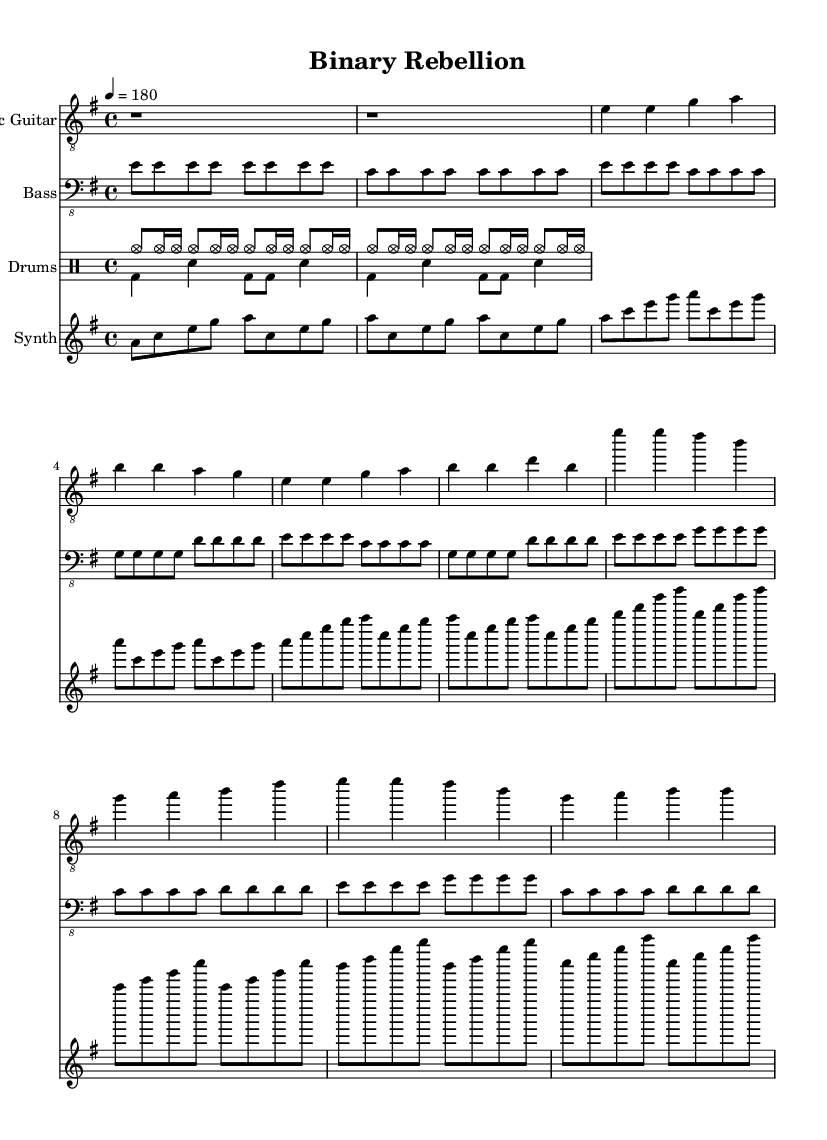What is the key signature of this music? The key signature indicates E minor, which has one sharp (F#). You can identify this by looking at the key signature symbol on the left side of the staff.
Answer: E minor What is the time signature of this music? The time signature is 4/4, meaning there are four beats in each measure and a quarter note gets one beat. This is indicated by the "4/4" notation at the beginning of the score.
Answer: 4/4 What is the tempo marking of this piece? The tempo marking, set at a quarter note equals 180 beats per minute, is indicated at the beginning of the score as "4 = 180". This tells the musician how fast to play the music.
Answer: 180 Which instrument plays the intro? The intro is played by the Electric Guitar, as noted at the beginning of the first staff. This is also visually indicated by the music notation that follows the instrument name.
Answer: Electric Guitar In which section do we first hear the synthesizer? The synthesizer is first heard in the Intro section, where its music notation for the introduction appears at the start of the part labeled for the synthesizer.
Answer: Intro How many measures are in the first verse? The first verse consists of four measures, which can be counted by looking at the music notation under the Electric Guitar staff where the verse is notated. Each measure is separated by vertical lines.
Answer: 4 What rhythm pattern is primarily used in the drum part? The predominant rhythm pattern in the drum part features a steady combination of cymbals and bass drums with snare hits, creating a driving punk rhythm. This can be deduced from the drummode notation displaying repetitive beat structures.
Answer: Driving 